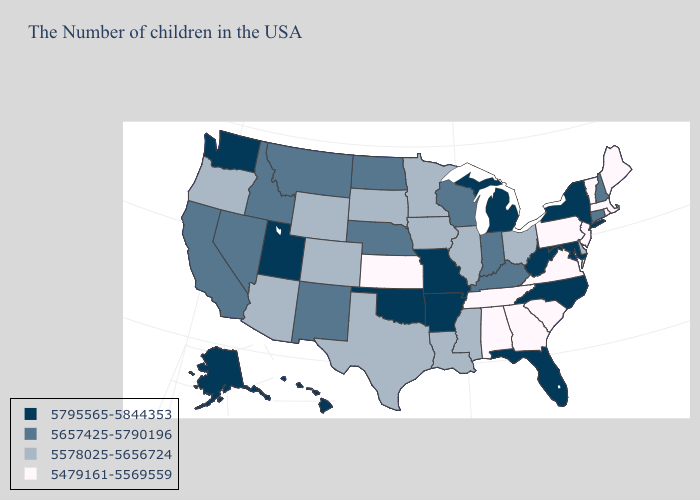Does the first symbol in the legend represent the smallest category?
Answer briefly. No. What is the value of Utah?
Write a very short answer. 5795565-5844353. What is the lowest value in states that border Vermont?
Quick response, please. 5479161-5569559. What is the highest value in the West ?
Quick response, please. 5795565-5844353. Does South Carolina have the highest value in the South?
Keep it brief. No. Which states have the lowest value in the USA?
Give a very brief answer. Maine, Massachusetts, Rhode Island, Vermont, New Jersey, Pennsylvania, Virginia, South Carolina, Georgia, Alabama, Tennessee, Kansas. Does Alaska have the highest value in the USA?
Quick response, please. Yes. What is the lowest value in states that border Rhode Island?
Write a very short answer. 5479161-5569559. What is the highest value in the USA?
Short answer required. 5795565-5844353. How many symbols are there in the legend?
Give a very brief answer. 4. Does the first symbol in the legend represent the smallest category?
Write a very short answer. No. Name the states that have a value in the range 5578025-5656724?
Keep it brief. Delaware, Ohio, Illinois, Mississippi, Louisiana, Minnesota, Iowa, Texas, South Dakota, Wyoming, Colorado, Arizona, Oregon. Name the states that have a value in the range 5657425-5790196?
Answer briefly. New Hampshire, Connecticut, Kentucky, Indiana, Wisconsin, Nebraska, North Dakota, New Mexico, Montana, Idaho, Nevada, California. Name the states that have a value in the range 5795565-5844353?
Short answer required. New York, Maryland, North Carolina, West Virginia, Florida, Michigan, Missouri, Arkansas, Oklahoma, Utah, Washington, Alaska, Hawaii. What is the highest value in the West ?
Write a very short answer. 5795565-5844353. 